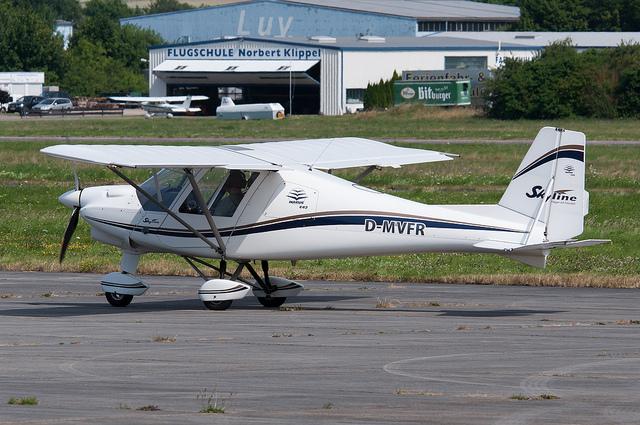Did the plane land in the middle of a field?
Short answer required. No. What is the name painted on the side of the plane?
Concise answer only. D-mvfr. How many people are with the plane?
Concise answer only. 1. Is this at an airport?
Quick response, please. Yes. What is this place?
Give a very brief answer. Airport. What is the last letter on the tail of the plane?
Quick response, please. E. 